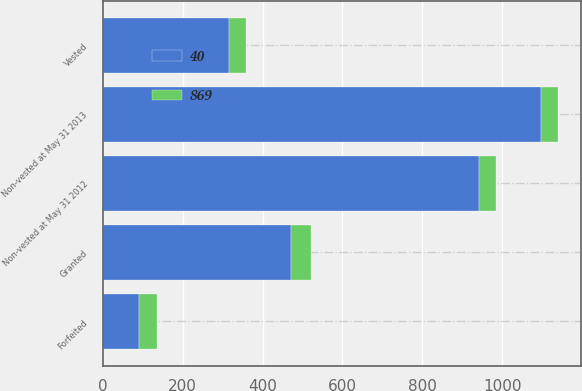<chart> <loc_0><loc_0><loc_500><loc_500><stacked_bar_chart><ecel><fcel>Granted<fcel>Non-vested at May 31 2012<fcel>Vested<fcel>Forfeited<fcel>Non-vested at May 31 2013<nl><fcel>40<fcel>472<fcel>941<fcel>315<fcel>91<fcel>1096<nl><fcel>869<fcel>48<fcel>44<fcel>43<fcel>44<fcel>44<nl></chart> 